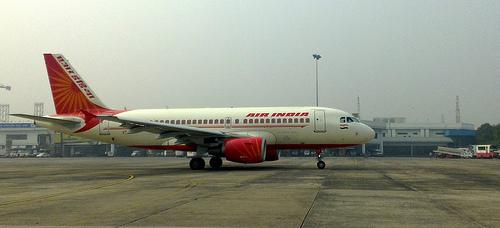Question: what is red?
Choices:
A. Stop sign.
B. Dress.
C. Plane's tail.
D. Car.
Answer with the letter. Answer: C Question: why does the plane have wings?
Choices:
A. To balance the plane.
B. To allow plane to glide.
C. To hold the motors.
D. To fly.
Answer with the letter. Answer: D Question: what is white and red?
Choices:
A. Plane.
B. Candy cane.
C. Stop sign.
D. Dress.
Answer with the letter. Answer: A Question: what is cloudy?
Choices:
A. Water.
B. Picture.
C. Memory.
D. Sky.
Answer with the letter. Answer: D 